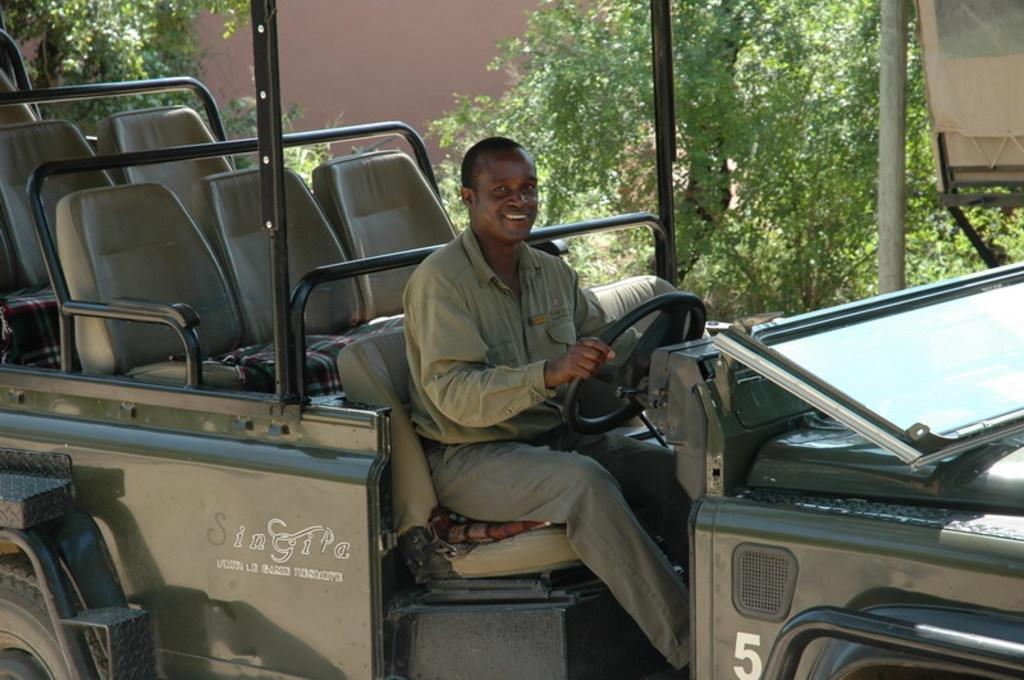What is the main subject of the image? There is a man in the image. What is the man doing in the image? The man is sitting on a seat and smiling. What is the man holding in the image? The man is holding a steering wheel. What objects can be seen in the background of the image? There are poles, a banner, leaves, and a wall visible in the background of the image. How many pigs are visible in the image? There are no pigs present in the image. What is the man's wish while sitting on the seat? There is no information about the man's wishes in the image. 